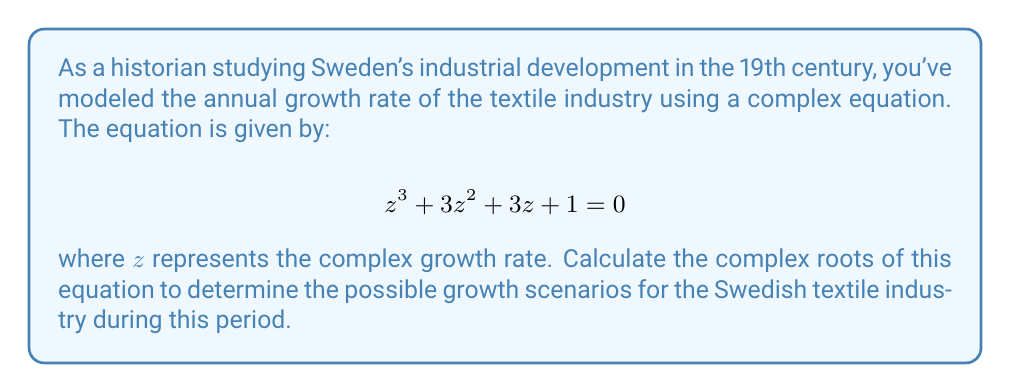Teach me how to tackle this problem. To solve this equation, we can follow these steps:

1) First, we recognize that this equation is in the form of a depressed cubic equation:

   $$z^3 + pz^2 + qz + r = 0$$

   where $p = 3$, $q = 3$, and $r = 1$.

2) We can factor out $(z + 1)$ from this equation:

   $$z^3 + 3z^2 + 3z + 1 = (z + 1)(z^2 + 2z + 1) = 0$$

3) From this, we can see that one root is $z = -1$.

4) The remaining quadratic equation $z^2 + 2z + 1 = 0$ can be solved using the quadratic formula:

   $$z = \frac{-b \pm \sqrt{b^2 - 4ac}}{2a}$$

   where $a = 1$, $b = 2$, and $c = 1$.

5) Substituting these values:

   $$z = \frac{-2 \pm \sqrt{4 - 4}}{2} = \frac{-2 \pm 0}{2} = -1$$

6) Therefore, the equation has a triple root at $z = -1$.

In the context of industrial growth, a negative root suggests a declining growth rate. The triple root at -1 indicates that the model predicts a consistent decline in the growth rate of the Swedish textile industry during this period.
Answer: The complex roots of the equation are: $z_1 = z_2 = z_3 = -1$ 